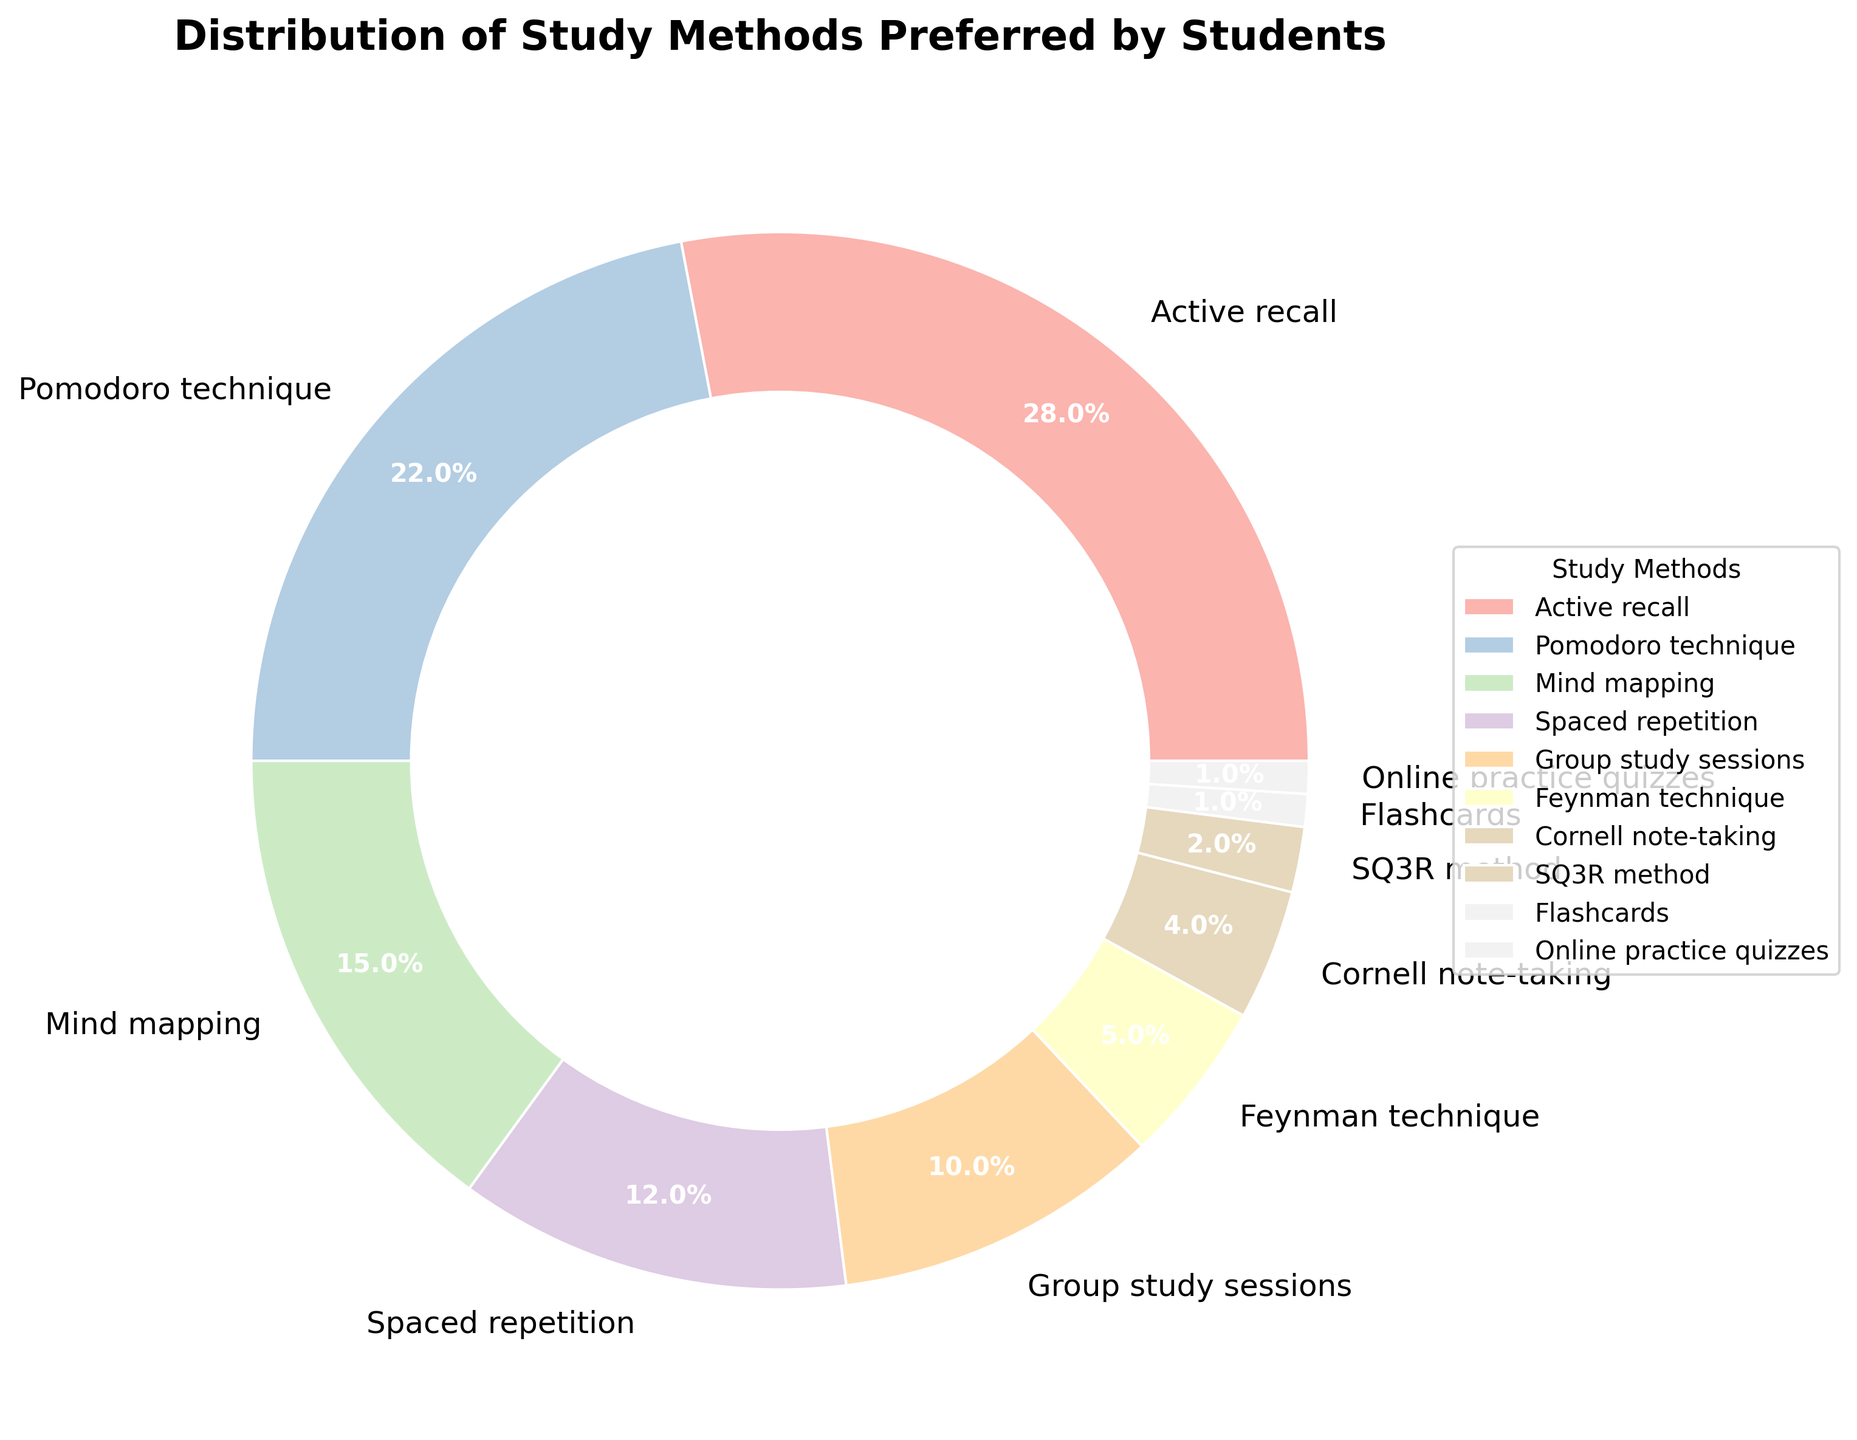what percentage of students prefer the Pomodoro technique? The figure shows the distribution of study methods, with the percentage labels. According to the label for the Pomodoro technique, it is 22%.
Answer: 22% What is the total percentage of students who prefer either Active recall or Spaced repetition? The figure shows the percentages for each study method. Add the percentage of Active recall (28%) and Spaced repetition (12%). 28% + 12% = 40%.
Answer: 40% Which two study methods combined account for more than 50% of the distribution? By adding the percentages shown for each method until the sum exceeds 50%, we find that Active recall (28%) and Pomodoro technique (22%) together make 28% + 22% = 50%, which is not more than 50%. Adding Mind mapping (15%) to the previous sum gives 50% + 15% = 65%.
Answer: Active recall and Pomodoro technique What is the difference in percentage points between the highest and lowest preferred study methods? The highest preferred method is Active recall (28%) and the lowest is both Flashcards and Online practice quizzes (1% each). Subtract the lowest percentage from the highest percentage: 28% - 1% = 27%.
Answer: 27% Which study method is represented by the second smallest segment in the pie chart? The second smallest segment is slightly larger than the smallest segments, which are both Flashcards and Online practice quizzes (each at 1%). The second smallest percentage is SQ3R method (2%).
Answer: SQ3R method What percentage of students prefer Group study sessions plus Feynman technique? The figure shows percentages for Group study sessions (10%) and Feynman technique (5%). Add these percentages together: 10% + 5% = 15%.
Answer: 15% Do more students prefer Mind mapping or Cornell note-taking? Compare the percentages for Mind mapping (15%) and Cornell note-taking (4%). 15% is greater than 4%.
Answer: Mind mapping Which study method has a percentage almost equivalent to the combined percentage of Feynman technique and Flashcards? Feynman technique has 5% and Flashcards has 1%. Their combined total is 5% + 1% = 6%. The closest percentage to 6% is none, but the nearest comparable figure is Group study sessions with 10%.
Answer: None (the closest is Group study sessions with 10%) What are the visual attributes used to differentiate between the study methods in the pie chart? The pie chart uses different pastel colors for each study method and includes percentage labels for distinction.
Answer: Different pastel colors and percentage labels 